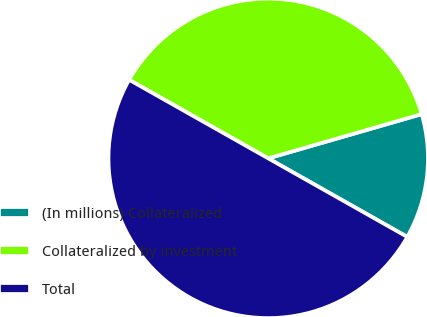Convert chart. <chart><loc_0><loc_0><loc_500><loc_500><pie_chart><fcel>(In millions) Collateralized<fcel>Collateralized by investment<fcel>Total<nl><fcel>12.65%<fcel>37.35%<fcel>50.0%<nl></chart> 